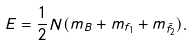<formula> <loc_0><loc_0><loc_500><loc_500>E = \frac { 1 } { 2 } N ( m _ { B } + m _ { f _ { 1 } } + m _ { \bar { f _ { 2 } } } ) .</formula> 